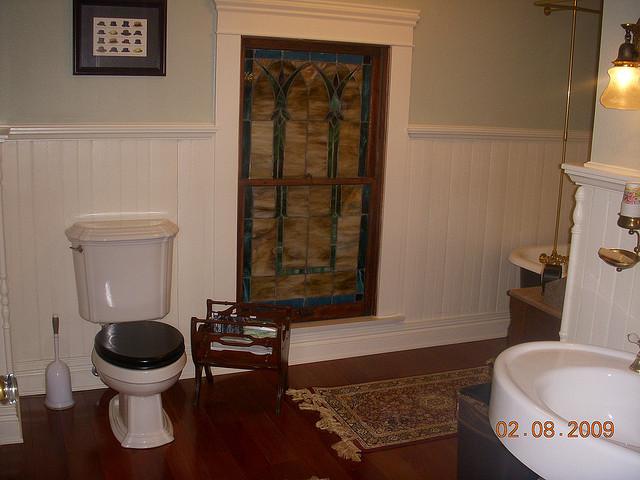Does the toilet's lid match the rest of it?
Concise answer only. No. What date was this picture taken?
Short answer required. 02.08.2009. Is the light off?
Write a very short answer. No. Is there t.p.?
Short answer required. No. 